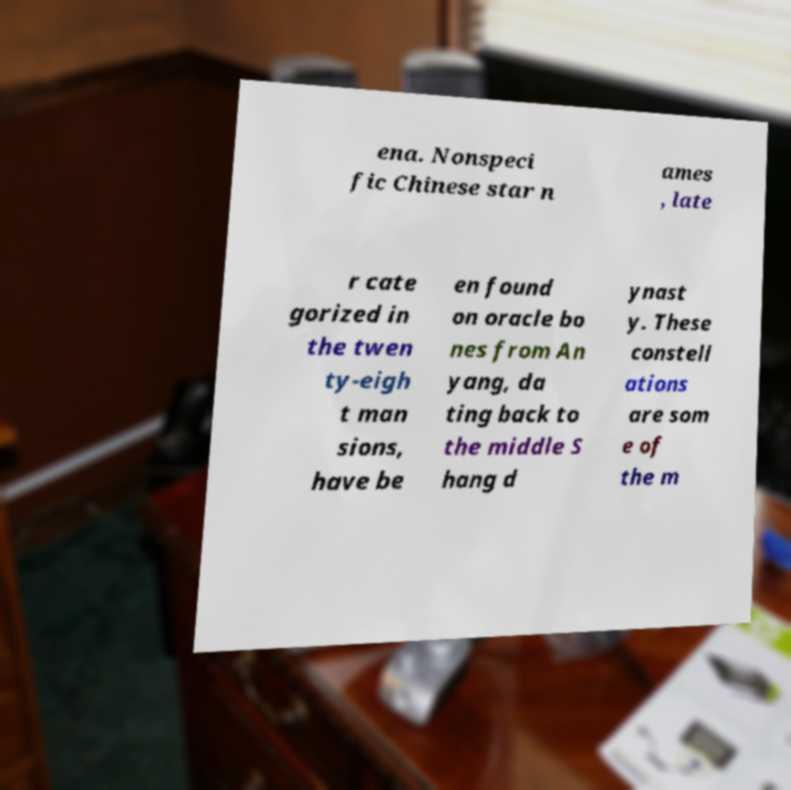Can you read and provide the text displayed in the image?This photo seems to have some interesting text. Can you extract and type it out for me? ena. Nonspeci fic Chinese star n ames , late r cate gorized in the twen ty-eigh t man sions, have be en found on oracle bo nes from An yang, da ting back to the middle S hang d ynast y. These constell ations are som e of the m 